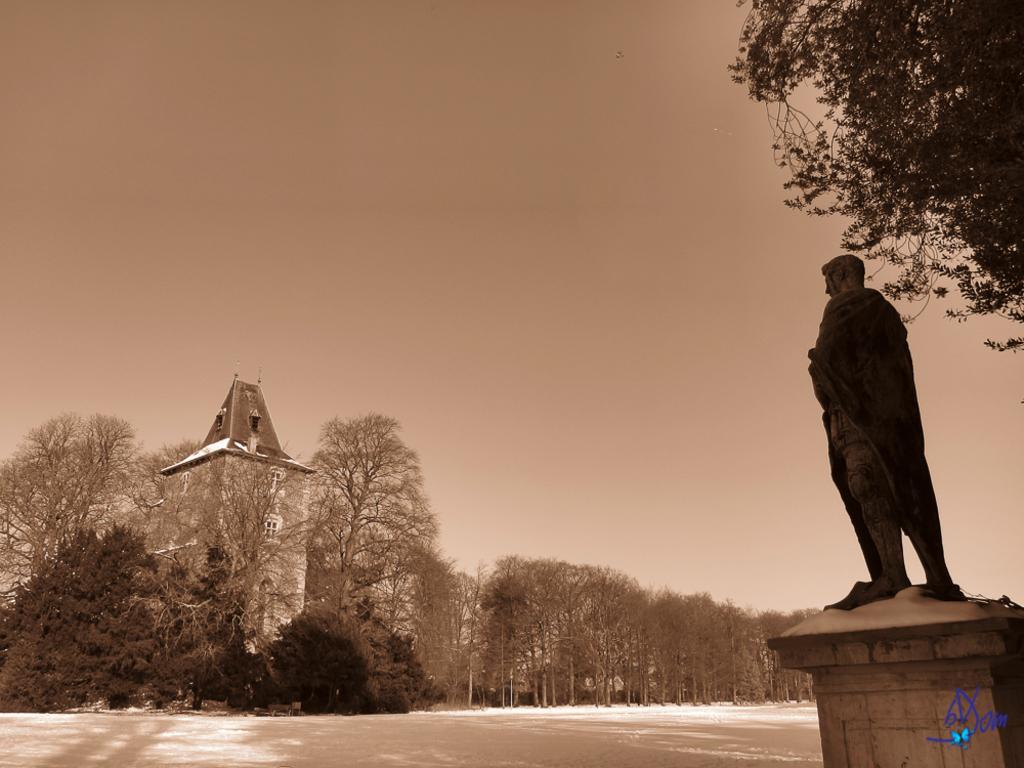Please provide a concise description of this image. In this image, we can see a building and a statue. We can see some plants and trees. We can also see the ground and the sky. We can also see some text on the bottom right corner. 